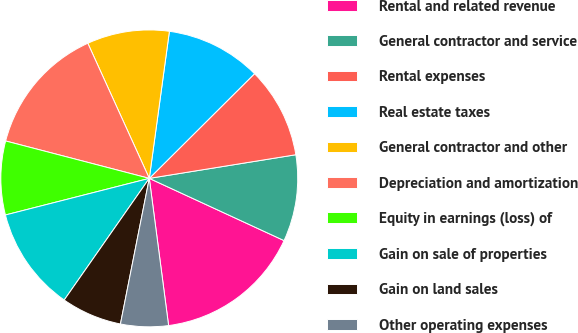Convert chart. <chart><loc_0><loc_0><loc_500><loc_500><pie_chart><fcel>Rental and related revenue<fcel>General contractor and service<fcel>Rental expenses<fcel>Real estate taxes<fcel>General contractor and other<fcel>Depreciation and amortization<fcel>Equity in earnings (loss) of<fcel>Gain on sale of properties<fcel>Gain on land sales<fcel>Other operating expenses<nl><fcel>16.04%<fcel>9.43%<fcel>9.91%<fcel>10.38%<fcel>8.96%<fcel>14.15%<fcel>8.02%<fcel>11.32%<fcel>6.6%<fcel>5.19%<nl></chart> 